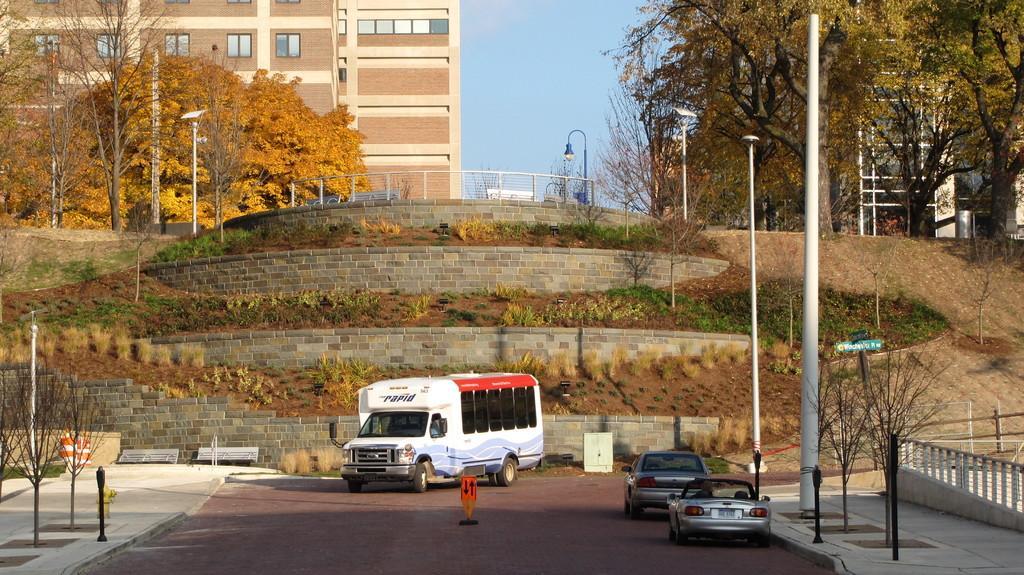How would you summarize this image in a sentence or two? In the foreground of the picture I can see a minivan and two cars on the road. There are deciduous trees on the left side and the right side as well. I can see the light poles on both sides of the road. I can see a fire hydrant on the side of the road and it is on the bottom left side of the picture. In the background, I can see the buildings and glass windows. There are clouds in the sky. 